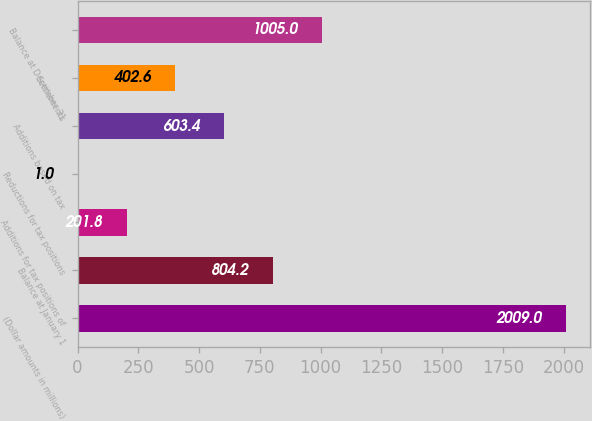Convert chart. <chart><loc_0><loc_0><loc_500><loc_500><bar_chart><fcel>(Dollar amounts in millions)<fcel>Balance at January 1<fcel>Additions for tax positions of<fcel>Reductions for tax positions<fcel>Additions based on tax<fcel>Settlements<fcel>Balance at December 31<nl><fcel>2009<fcel>804.2<fcel>201.8<fcel>1<fcel>603.4<fcel>402.6<fcel>1005<nl></chart> 